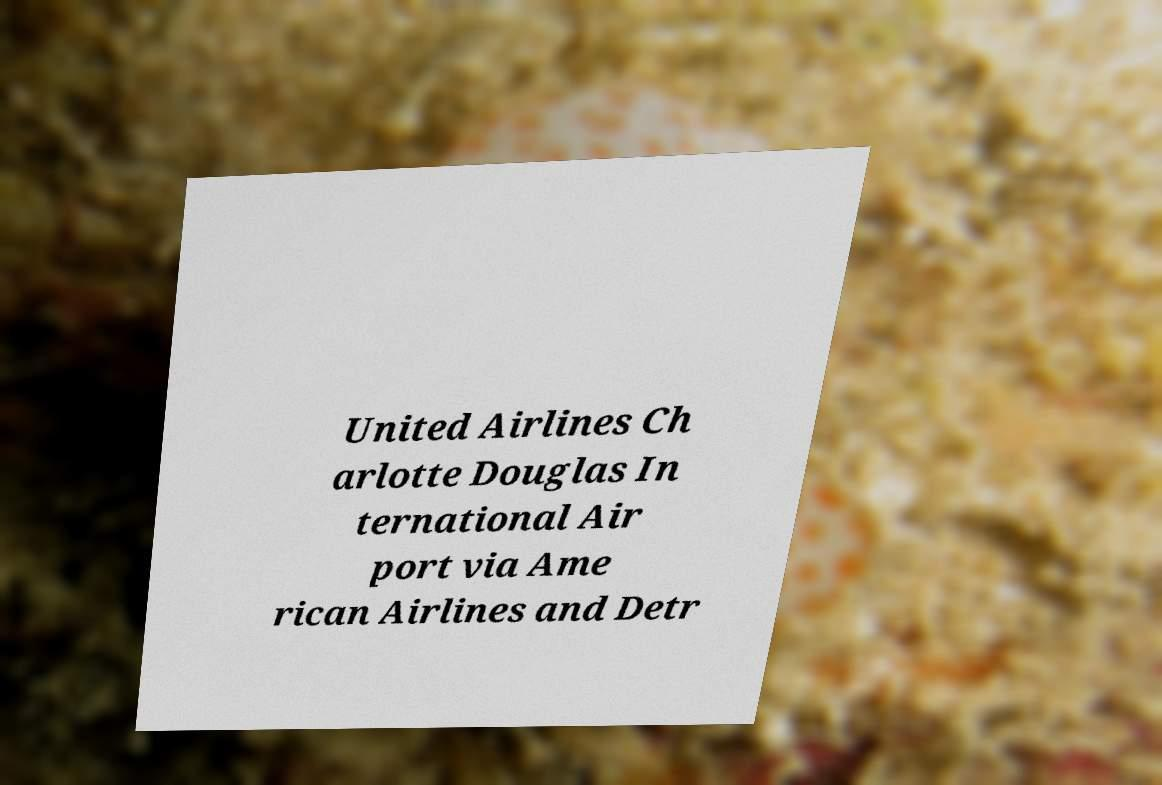For documentation purposes, I need the text within this image transcribed. Could you provide that? United Airlines Ch arlotte Douglas In ternational Air port via Ame rican Airlines and Detr 